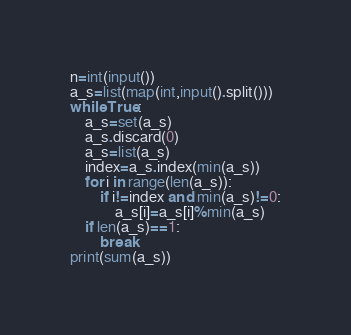Convert code to text. <code><loc_0><loc_0><loc_500><loc_500><_Python_>n=int(input())
a_s=list(map(int,input().split()))
while True:
    a_s=set(a_s)
    a_s.discard(0)
    a_s=list(a_s)
    index=a_s.index(min(a_s))
    for i in range(len(a_s)):
        if i!=index and min(a_s)!=0:
            a_s[i]=a_s[i]%min(a_s)
    if len(a_s)==1:
        break
print(sum(a_s))</code> 